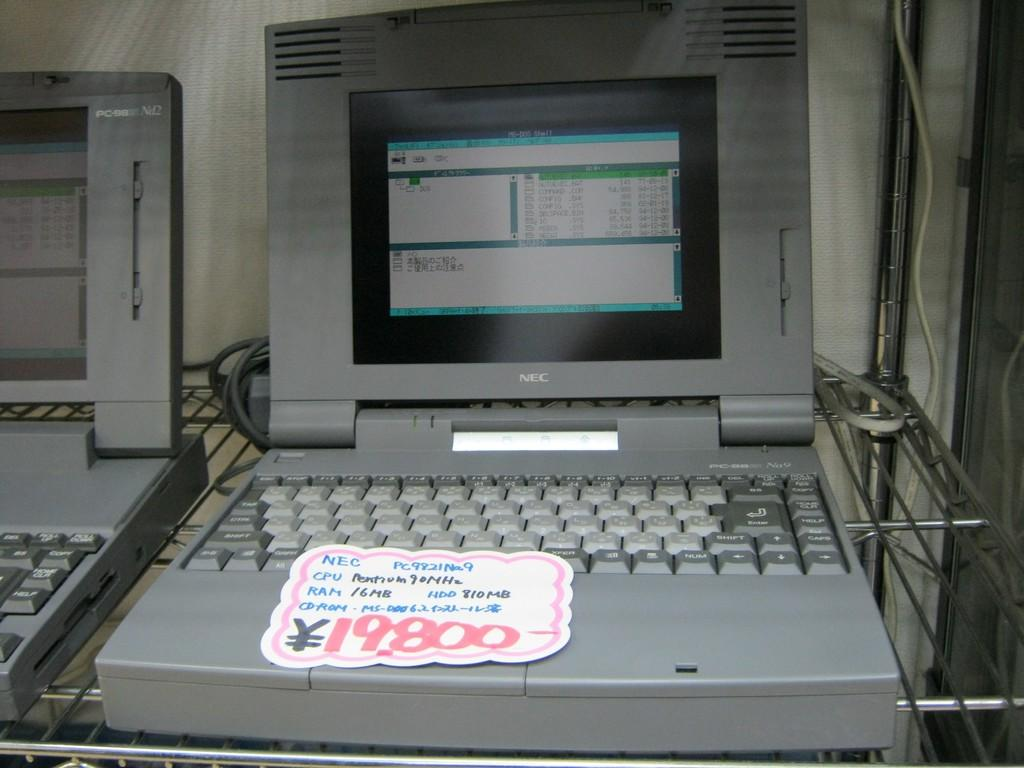<image>
Offer a succinct explanation of the picture presented. A old NEC computer is selling at 19,800 yen. 